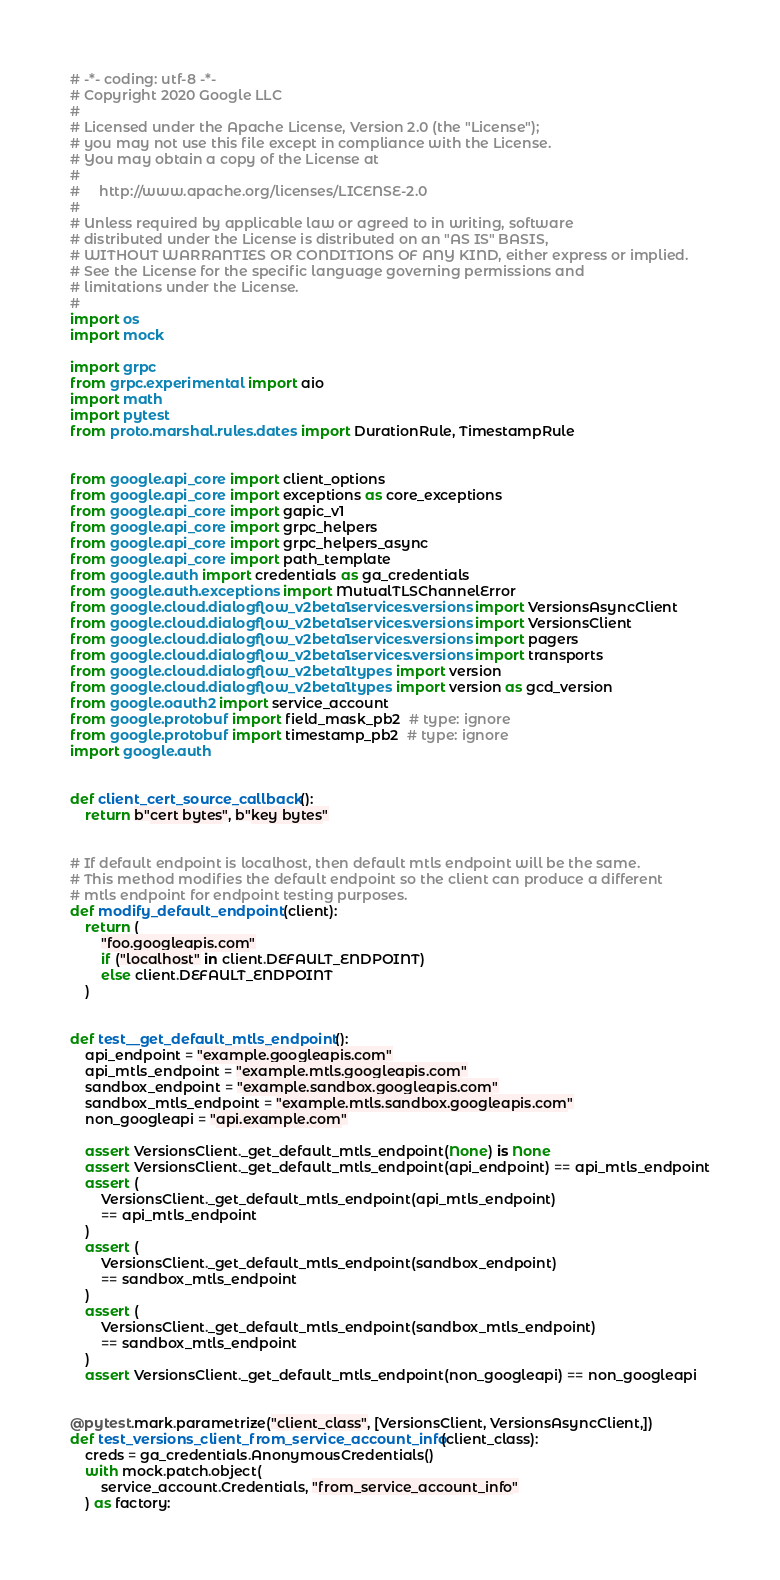<code> <loc_0><loc_0><loc_500><loc_500><_Python_># -*- coding: utf-8 -*-
# Copyright 2020 Google LLC
#
# Licensed under the Apache License, Version 2.0 (the "License");
# you may not use this file except in compliance with the License.
# You may obtain a copy of the License at
#
#     http://www.apache.org/licenses/LICENSE-2.0
#
# Unless required by applicable law or agreed to in writing, software
# distributed under the License is distributed on an "AS IS" BASIS,
# WITHOUT WARRANTIES OR CONDITIONS OF ANY KIND, either express or implied.
# See the License for the specific language governing permissions and
# limitations under the License.
#
import os
import mock

import grpc
from grpc.experimental import aio
import math
import pytest
from proto.marshal.rules.dates import DurationRule, TimestampRule


from google.api_core import client_options
from google.api_core import exceptions as core_exceptions
from google.api_core import gapic_v1
from google.api_core import grpc_helpers
from google.api_core import grpc_helpers_async
from google.api_core import path_template
from google.auth import credentials as ga_credentials
from google.auth.exceptions import MutualTLSChannelError
from google.cloud.dialogflow_v2beta1.services.versions import VersionsAsyncClient
from google.cloud.dialogflow_v2beta1.services.versions import VersionsClient
from google.cloud.dialogflow_v2beta1.services.versions import pagers
from google.cloud.dialogflow_v2beta1.services.versions import transports
from google.cloud.dialogflow_v2beta1.types import version
from google.cloud.dialogflow_v2beta1.types import version as gcd_version
from google.oauth2 import service_account
from google.protobuf import field_mask_pb2  # type: ignore
from google.protobuf import timestamp_pb2  # type: ignore
import google.auth


def client_cert_source_callback():
    return b"cert bytes", b"key bytes"


# If default endpoint is localhost, then default mtls endpoint will be the same.
# This method modifies the default endpoint so the client can produce a different
# mtls endpoint for endpoint testing purposes.
def modify_default_endpoint(client):
    return (
        "foo.googleapis.com"
        if ("localhost" in client.DEFAULT_ENDPOINT)
        else client.DEFAULT_ENDPOINT
    )


def test__get_default_mtls_endpoint():
    api_endpoint = "example.googleapis.com"
    api_mtls_endpoint = "example.mtls.googleapis.com"
    sandbox_endpoint = "example.sandbox.googleapis.com"
    sandbox_mtls_endpoint = "example.mtls.sandbox.googleapis.com"
    non_googleapi = "api.example.com"

    assert VersionsClient._get_default_mtls_endpoint(None) is None
    assert VersionsClient._get_default_mtls_endpoint(api_endpoint) == api_mtls_endpoint
    assert (
        VersionsClient._get_default_mtls_endpoint(api_mtls_endpoint)
        == api_mtls_endpoint
    )
    assert (
        VersionsClient._get_default_mtls_endpoint(sandbox_endpoint)
        == sandbox_mtls_endpoint
    )
    assert (
        VersionsClient._get_default_mtls_endpoint(sandbox_mtls_endpoint)
        == sandbox_mtls_endpoint
    )
    assert VersionsClient._get_default_mtls_endpoint(non_googleapi) == non_googleapi


@pytest.mark.parametrize("client_class", [VersionsClient, VersionsAsyncClient,])
def test_versions_client_from_service_account_info(client_class):
    creds = ga_credentials.AnonymousCredentials()
    with mock.patch.object(
        service_account.Credentials, "from_service_account_info"
    ) as factory:</code> 